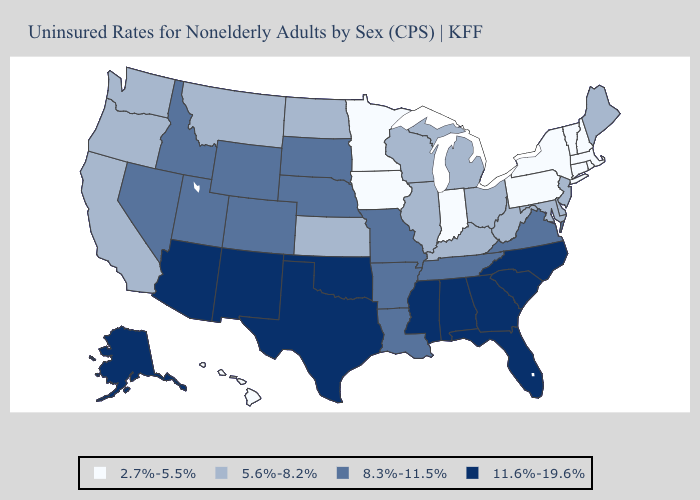Name the states that have a value in the range 11.6%-19.6%?
Give a very brief answer. Alabama, Alaska, Arizona, Florida, Georgia, Mississippi, New Mexico, North Carolina, Oklahoma, South Carolina, Texas. What is the highest value in the Northeast ?
Give a very brief answer. 5.6%-8.2%. Does the first symbol in the legend represent the smallest category?
Answer briefly. Yes. Which states have the highest value in the USA?
Keep it brief. Alabama, Alaska, Arizona, Florida, Georgia, Mississippi, New Mexico, North Carolina, Oklahoma, South Carolina, Texas. What is the highest value in states that border Nevada?
Keep it brief. 11.6%-19.6%. What is the lowest value in the South?
Write a very short answer. 5.6%-8.2%. Does North Dakota have a higher value than Idaho?
Quick response, please. No. Does Nevada have a lower value than Florida?
Answer briefly. Yes. What is the lowest value in the USA?
Concise answer only. 2.7%-5.5%. What is the value of Rhode Island?
Write a very short answer. 2.7%-5.5%. What is the highest value in states that border New York?
Short answer required. 5.6%-8.2%. How many symbols are there in the legend?
Write a very short answer. 4. What is the lowest value in the West?
Keep it brief. 2.7%-5.5%. Which states hav the highest value in the Northeast?
Keep it brief. Maine, New Jersey. 